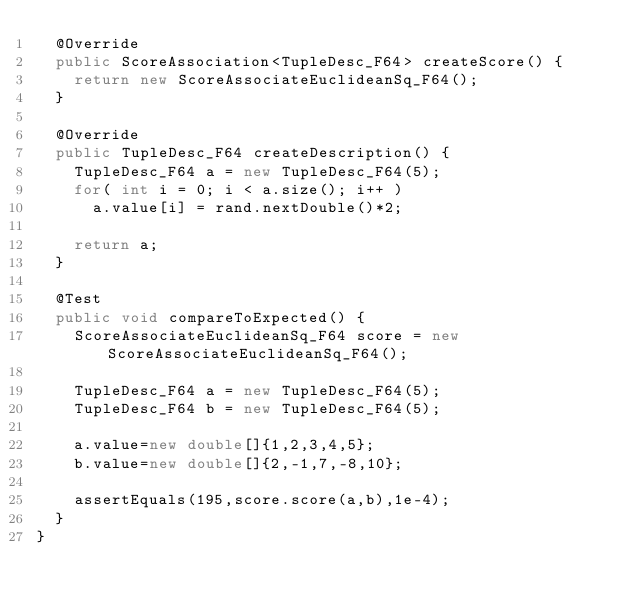<code> <loc_0><loc_0><loc_500><loc_500><_Java_>	@Override
	public ScoreAssociation<TupleDesc_F64> createScore() {
		return new ScoreAssociateEuclideanSq_F64();
	}

	@Override
	public TupleDesc_F64 createDescription() {
		TupleDesc_F64 a = new TupleDesc_F64(5);
		for( int i = 0; i < a.size(); i++ )
			a.value[i] = rand.nextDouble()*2;

		return a;
	}

	@Test
	public void compareToExpected() {
		ScoreAssociateEuclideanSq_F64 score = new ScoreAssociateEuclideanSq_F64();

		TupleDesc_F64 a = new TupleDesc_F64(5);
		TupleDesc_F64 b = new TupleDesc_F64(5);

		a.value=new double[]{1,2,3,4,5};
		b.value=new double[]{2,-1,7,-8,10};

		assertEquals(195,score.score(a,b),1e-4);
	}
}
</code> 